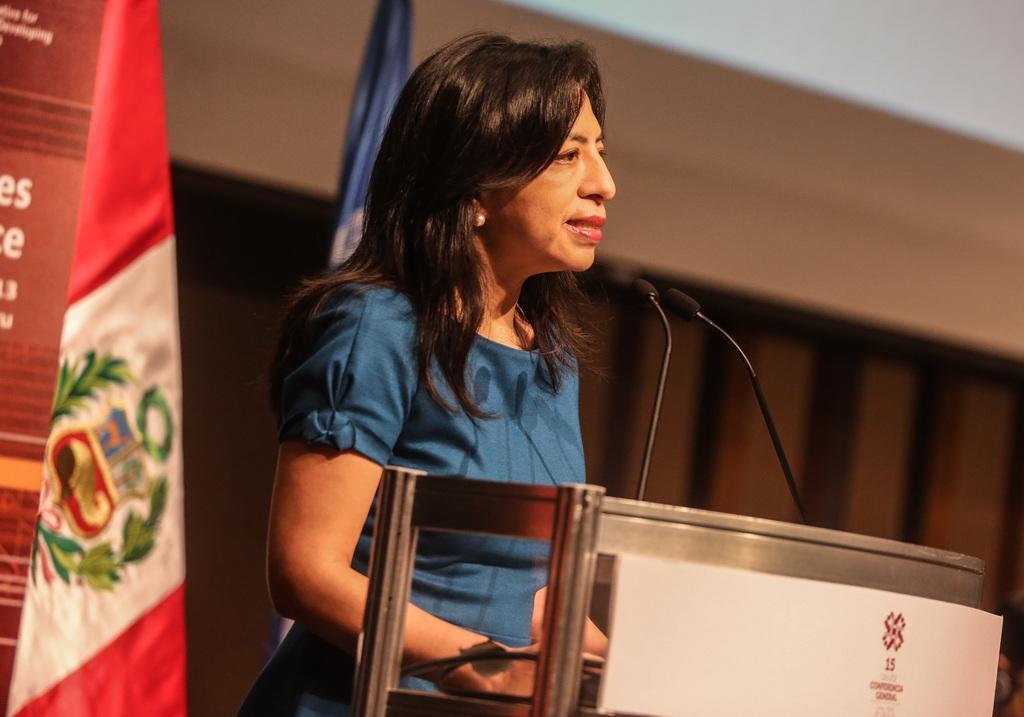Please provide a concise description of this image. In this picture there is a woman who is standing near to the speech desk and mics. Behind her I can see two flags. On the left there is a banner which is placed near to the flags. In the background I can see the wall and blur image. 